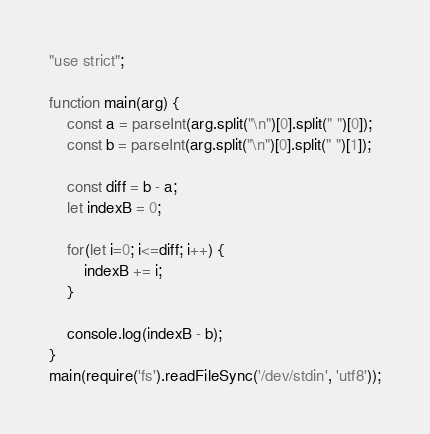<code> <loc_0><loc_0><loc_500><loc_500><_JavaScript_>"use strict";

function main(arg) {
    const a = parseInt(arg.split("\n")[0].split(" ")[0]);
    const b = parseInt(arg.split("\n")[0].split(" ")[1]);
    
    const diff = b - a;
    let indexB = 0;
    
    for(let i=0; i<=diff; i++) {
        indexB += i;
    }
    
    console.log(indexB - b);
}
main(require('fs').readFileSync('/dev/stdin', 'utf8'));</code> 